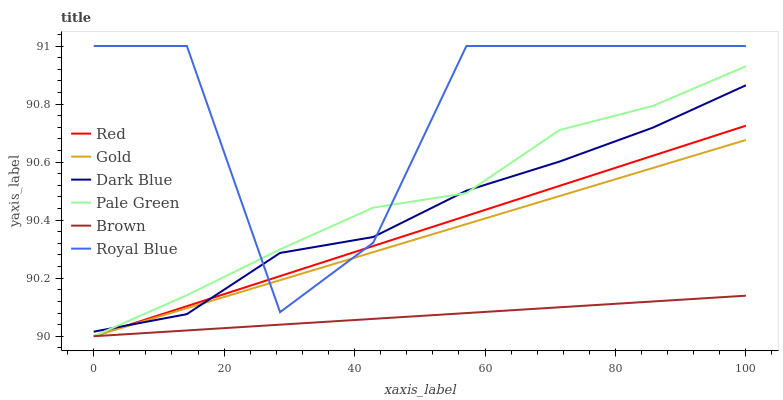Does Brown have the minimum area under the curve?
Answer yes or no. Yes. Does Royal Blue have the maximum area under the curve?
Answer yes or no. Yes. Does Gold have the minimum area under the curve?
Answer yes or no. No. Does Gold have the maximum area under the curve?
Answer yes or no. No. Is Gold the smoothest?
Answer yes or no. Yes. Is Royal Blue the roughest?
Answer yes or no. Yes. Is Dark Blue the smoothest?
Answer yes or no. No. Is Dark Blue the roughest?
Answer yes or no. No. Does Brown have the lowest value?
Answer yes or no. Yes. Does Dark Blue have the lowest value?
Answer yes or no. No. Does Royal Blue have the highest value?
Answer yes or no. Yes. Does Gold have the highest value?
Answer yes or no. No. Is Brown less than Dark Blue?
Answer yes or no. Yes. Is Royal Blue greater than Brown?
Answer yes or no. Yes. Does Pale Green intersect Royal Blue?
Answer yes or no. Yes. Is Pale Green less than Royal Blue?
Answer yes or no. No. Is Pale Green greater than Royal Blue?
Answer yes or no. No. Does Brown intersect Dark Blue?
Answer yes or no. No. 